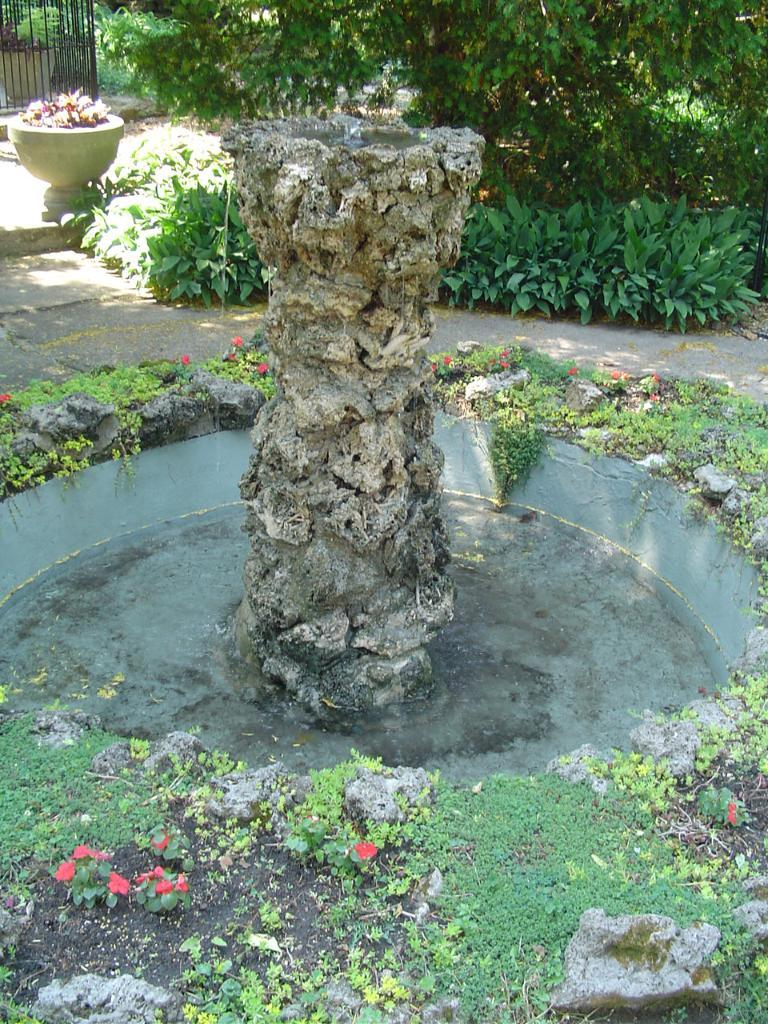What is the main feature in the image? There is a fountain in the image. Are there any plants near the fountain? Yes, there are small plants around the fountain. What can be seen in the background of the image? There are trees in the background of the image. What type of shirt is the bear wearing in the image? There is no bear or shirt present in the image. 